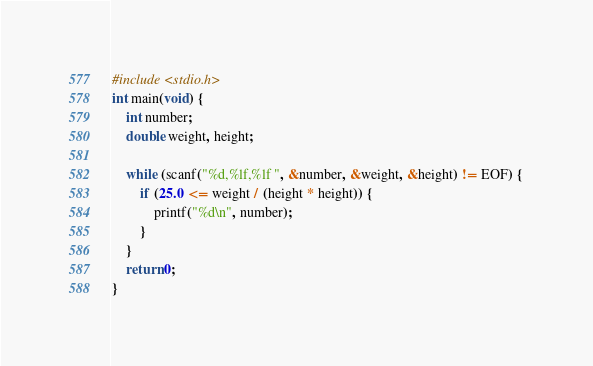<code> <loc_0><loc_0><loc_500><loc_500><_C_>#include <stdio.h>
int main(void) {
	int number;
	double weight, height;

	while (scanf("%d,%lf,%lf ", &number, &weight, &height) != EOF) {
		if (25.0 <= weight / (height * height)) {
			printf("%d\n", number);
		}
	}
	return 0;
}</code> 